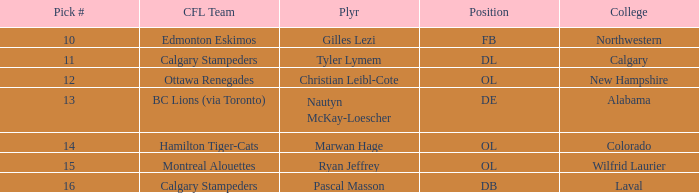Which player from the 2004 CFL draft attended Wilfrid Laurier? Ryan Jeffrey. 